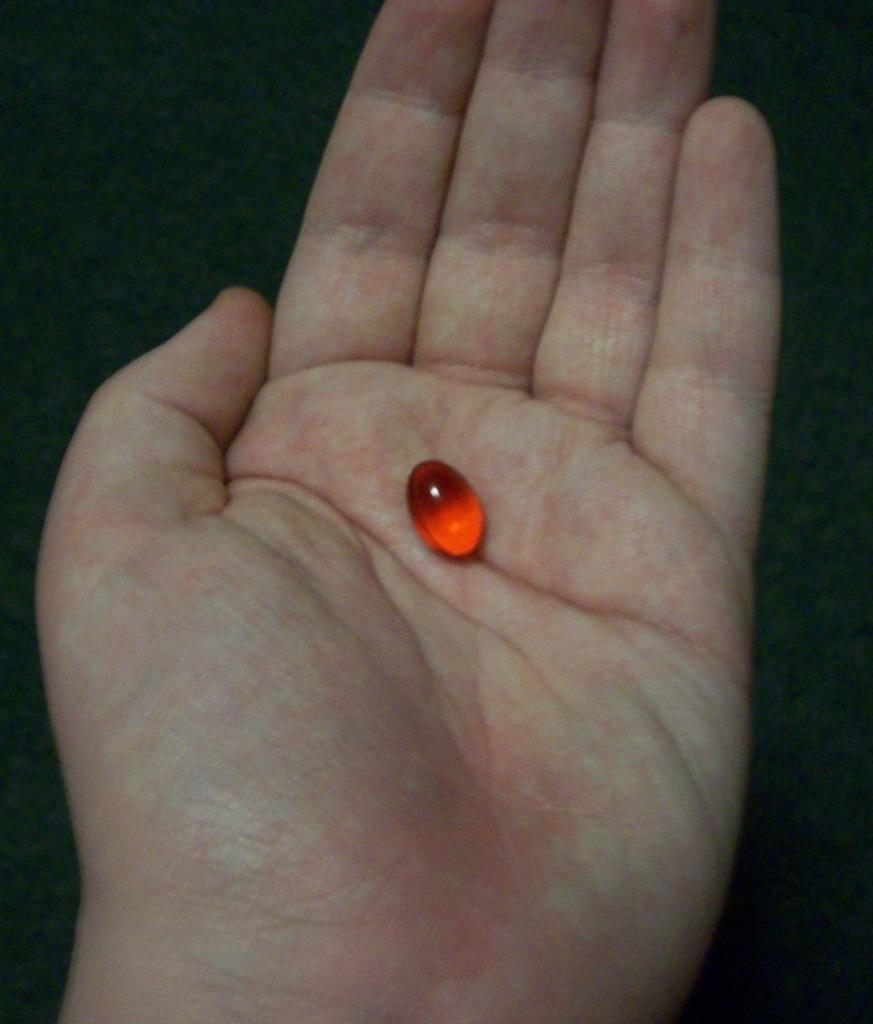How would you summarize this image in a sentence or two? In this image I can see a small red object on the hand of a person. And the background is dark. 